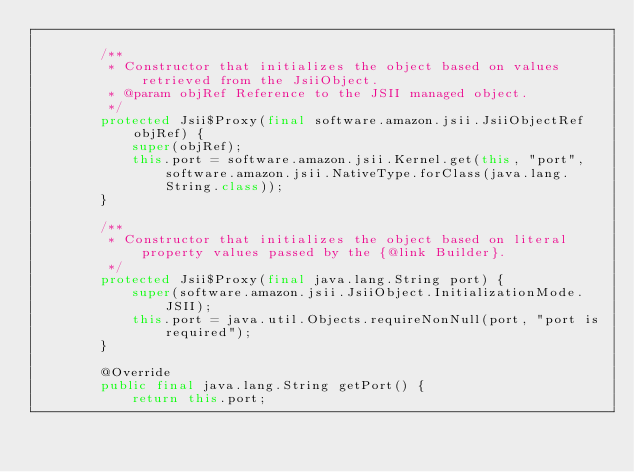Convert code to text. <code><loc_0><loc_0><loc_500><loc_500><_Java_>
        /**
         * Constructor that initializes the object based on values retrieved from the JsiiObject.
         * @param objRef Reference to the JSII managed object.
         */
        protected Jsii$Proxy(final software.amazon.jsii.JsiiObjectRef objRef) {
            super(objRef);
            this.port = software.amazon.jsii.Kernel.get(this, "port", software.amazon.jsii.NativeType.forClass(java.lang.String.class));
        }

        /**
         * Constructor that initializes the object based on literal property values passed by the {@link Builder}.
         */
        protected Jsii$Proxy(final java.lang.String port) {
            super(software.amazon.jsii.JsiiObject.InitializationMode.JSII);
            this.port = java.util.Objects.requireNonNull(port, "port is required");
        }

        @Override
        public final java.lang.String getPort() {
            return this.port;</code> 